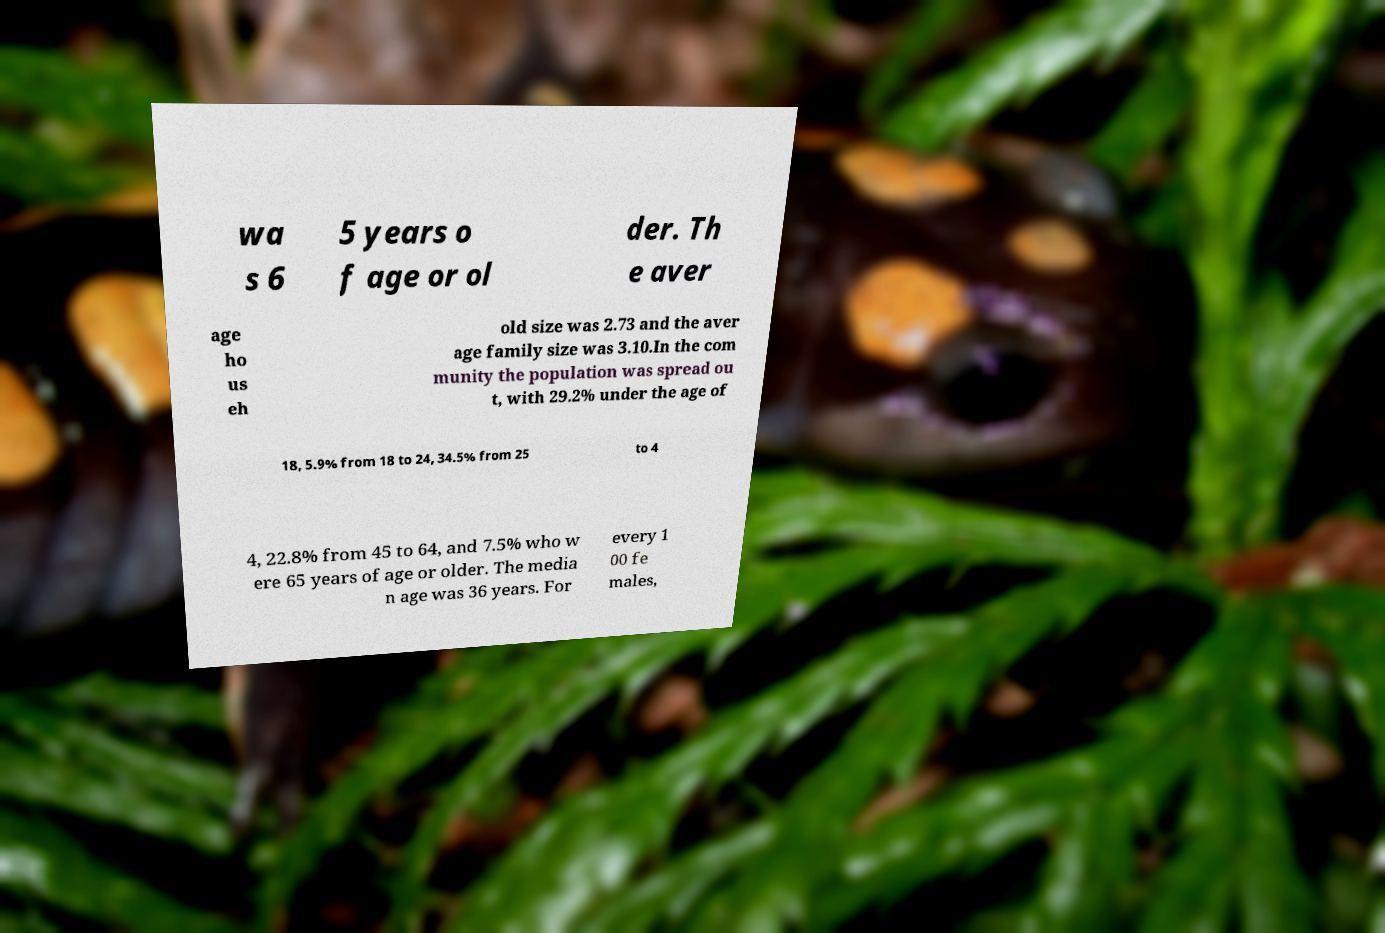Can you read and provide the text displayed in the image?This photo seems to have some interesting text. Can you extract and type it out for me? wa s 6 5 years o f age or ol der. Th e aver age ho us eh old size was 2.73 and the aver age family size was 3.10.In the com munity the population was spread ou t, with 29.2% under the age of 18, 5.9% from 18 to 24, 34.5% from 25 to 4 4, 22.8% from 45 to 64, and 7.5% who w ere 65 years of age or older. The media n age was 36 years. For every 1 00 fe males, 